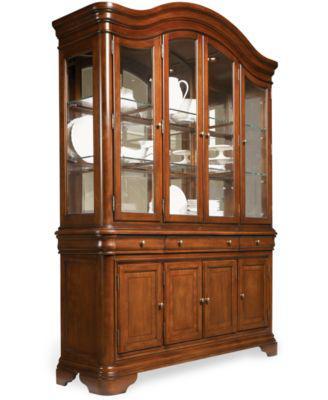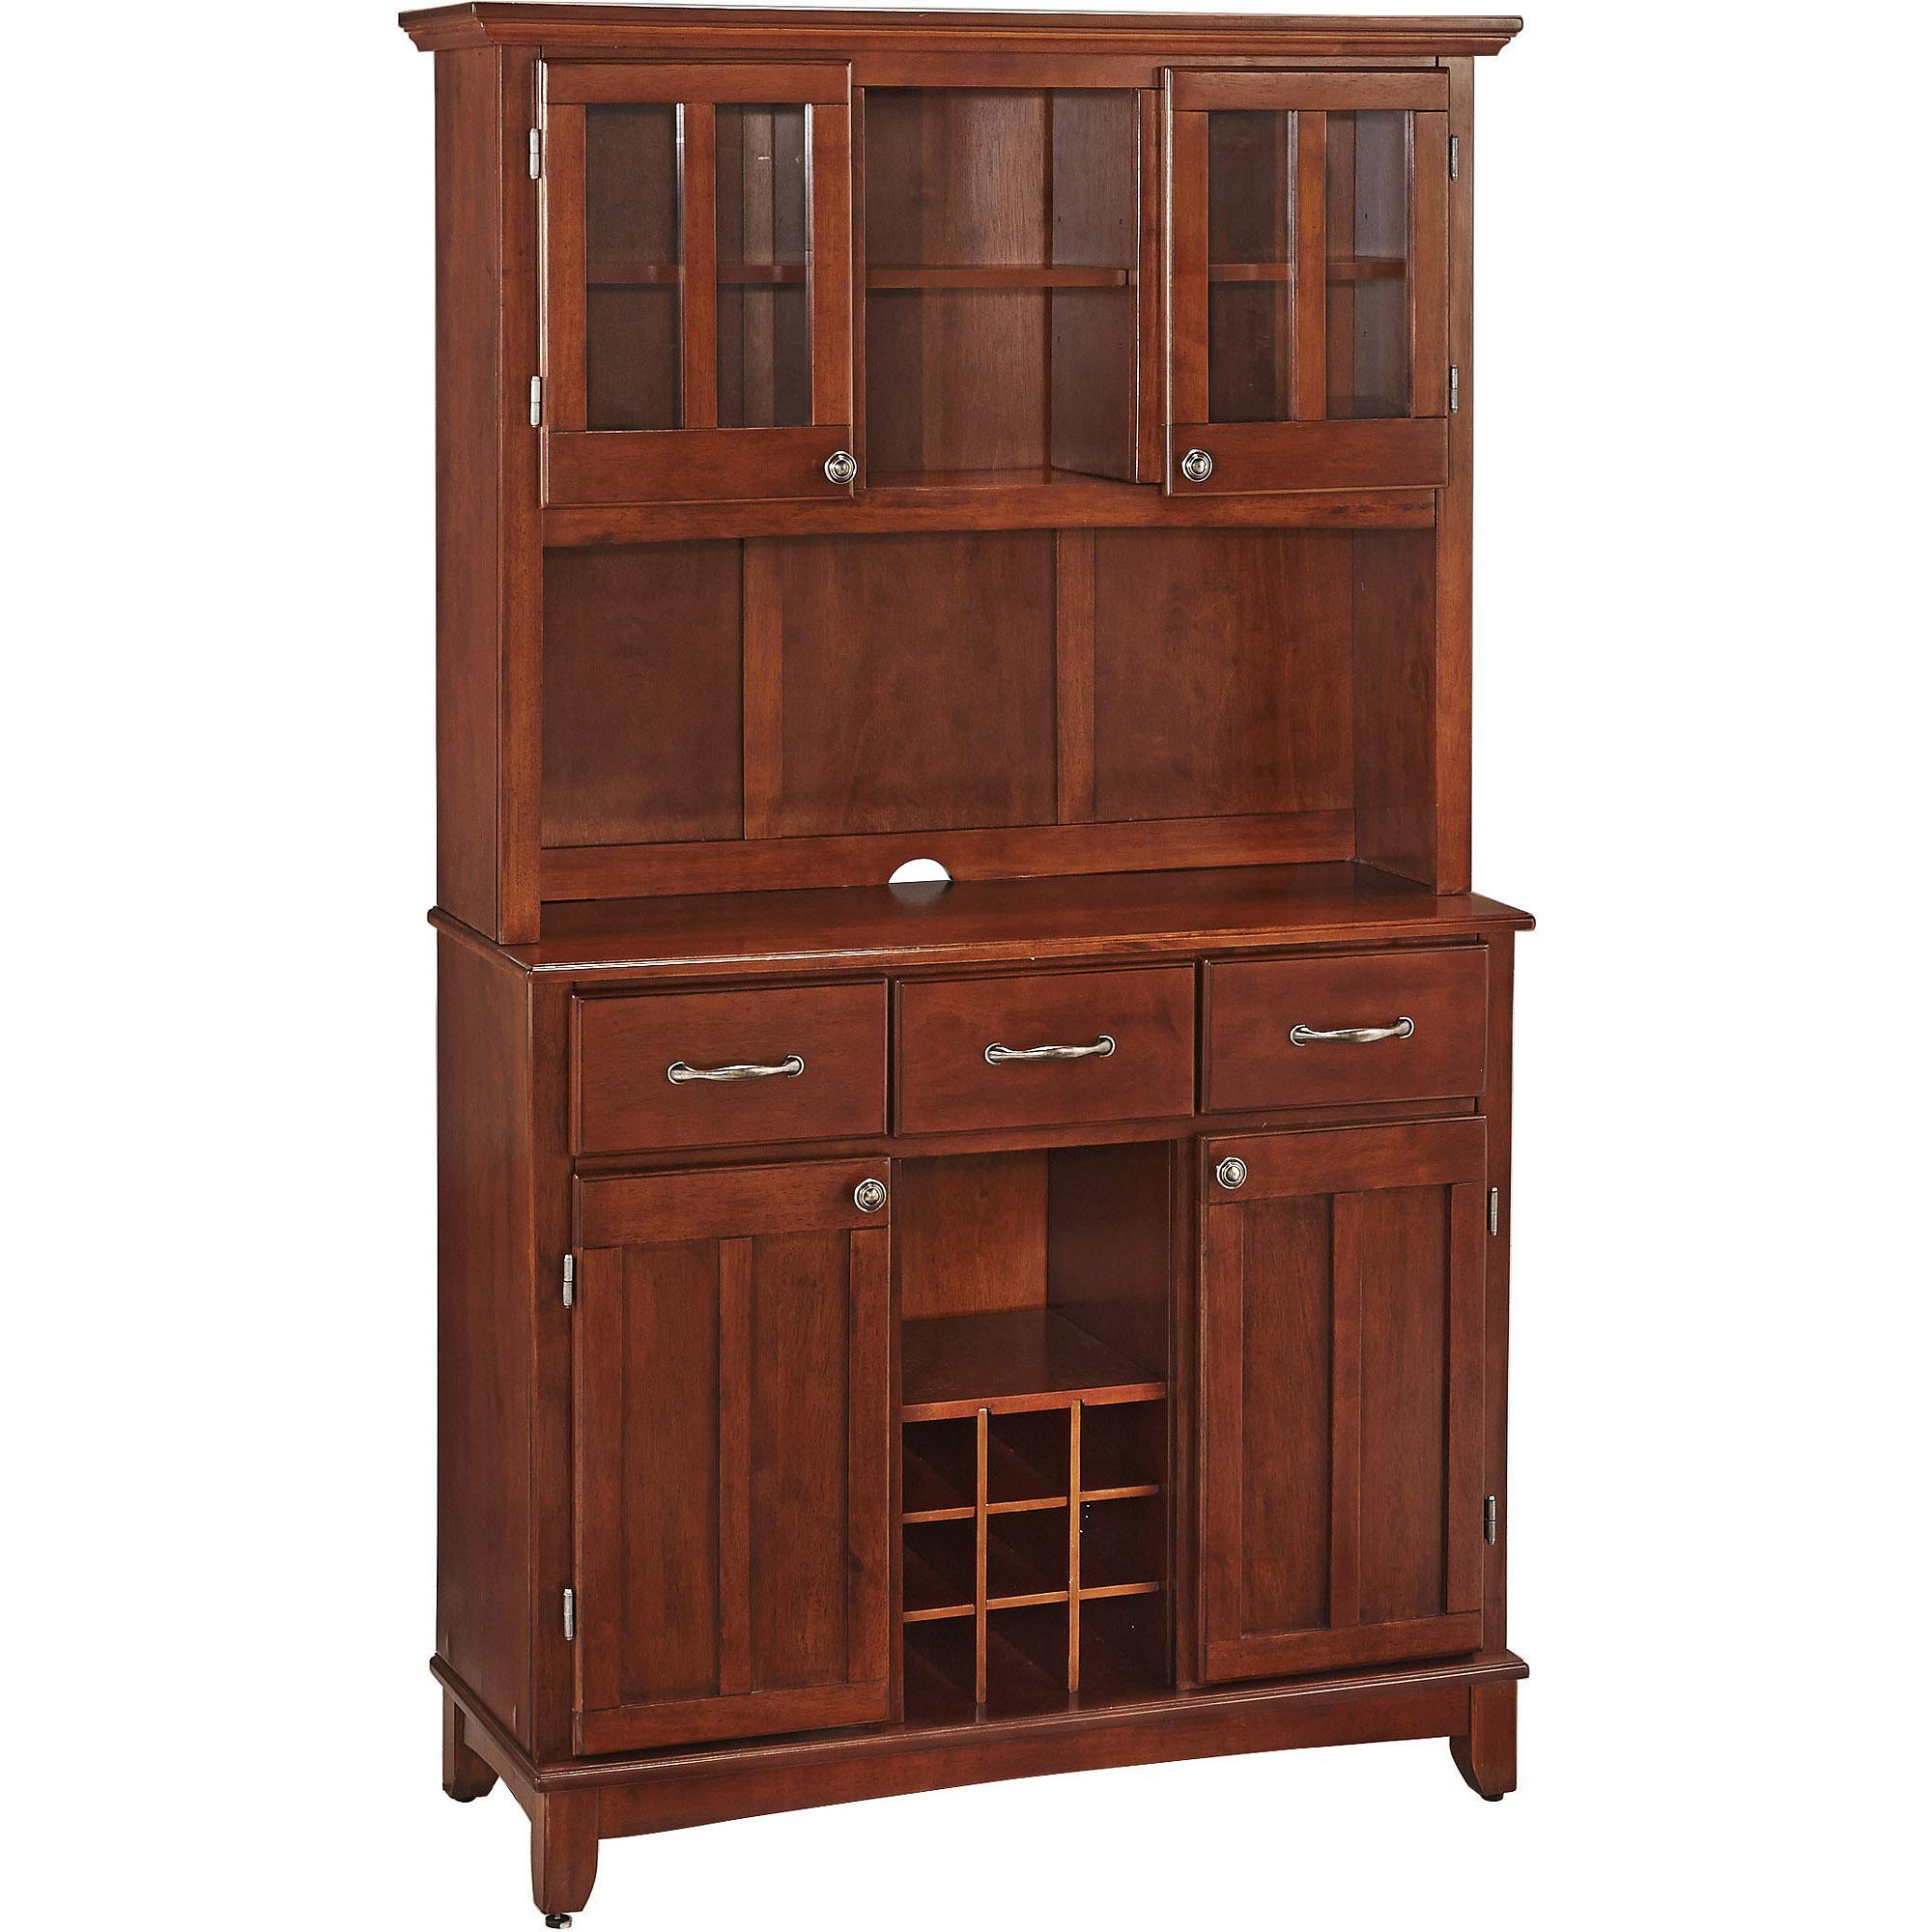The first image is the image on the left, the second image is the image on the right. Examine the images to the left and right. Is the description "One of the cabinets has a curving arched solid-wood top." accurate? Answer yes or no. Yes. 